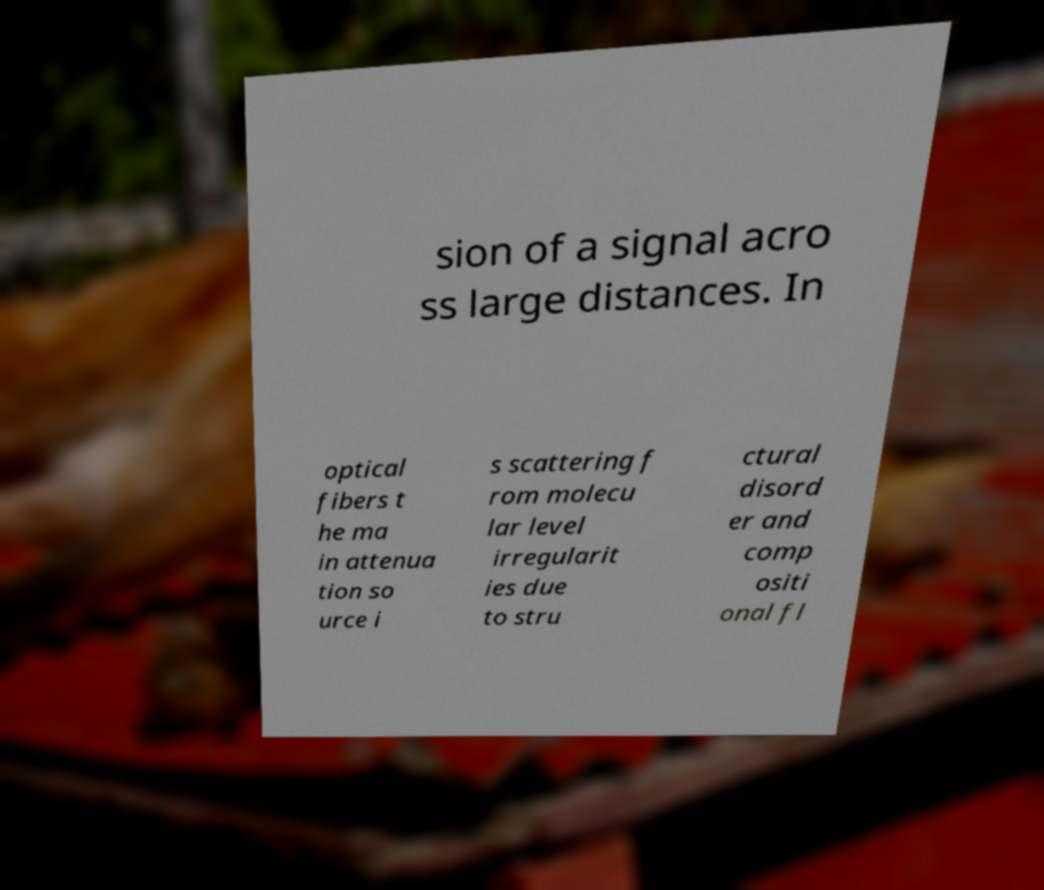There's text embedded in this image that I need extracted. Can you transcribe it verbatim? sion of a signal acro ss large distances. In optical fibers t he ma in attenua tion so urce i s scattering f rom molecu lar level irregularit ies due to stru ctural disord er and comp ositi onal fl 